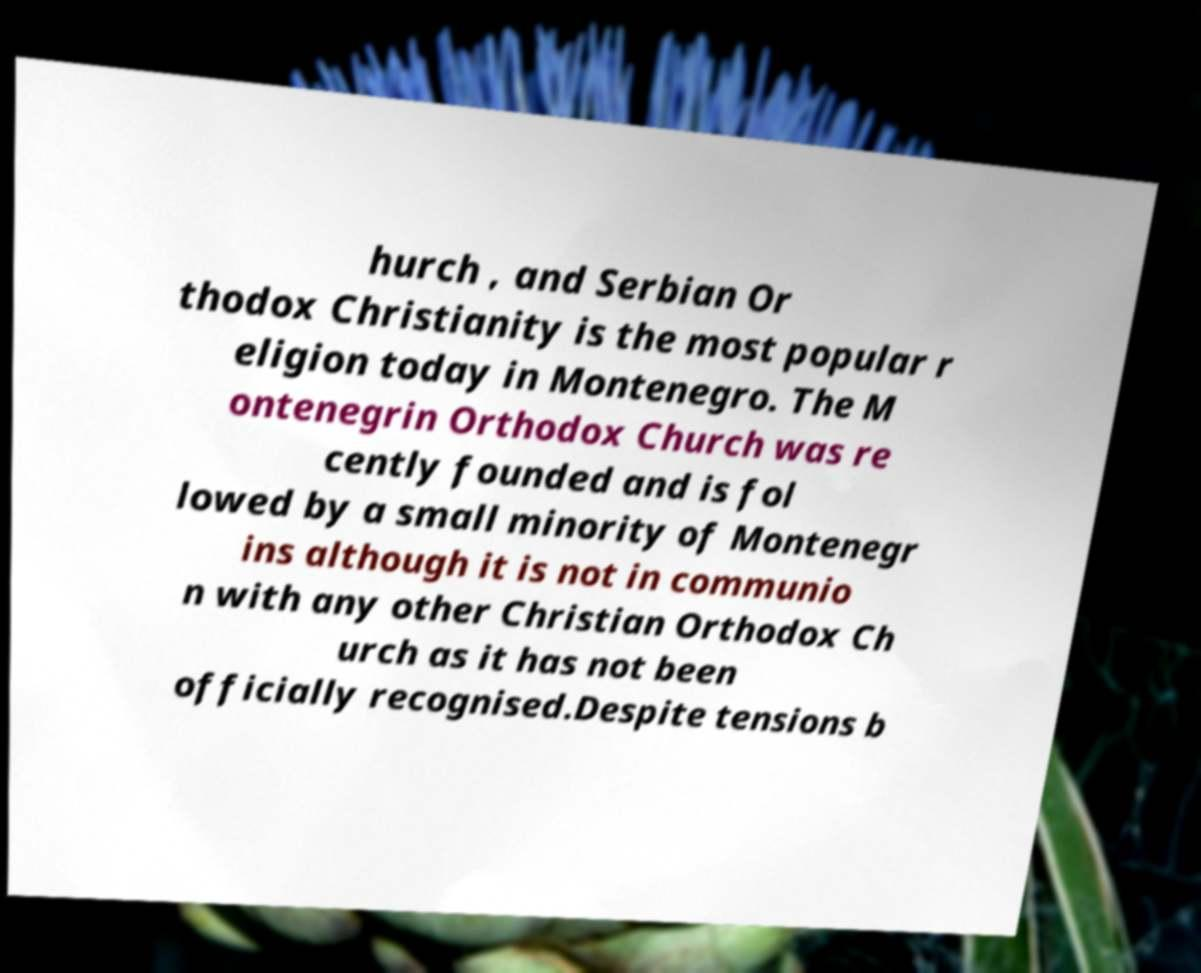Could you extract and type out the text from this image? hurch , and Serbian Or thodox Christianity is the most popular r eligion today in Montenegro. The M ontenegrin Orthodox Church was re cently founded and is fol lowed by a small minority of Montenegr ins although it is not in communio n with any other Christian Orthodox Ch urch as it has not been officially recognised.Despite tensions b 